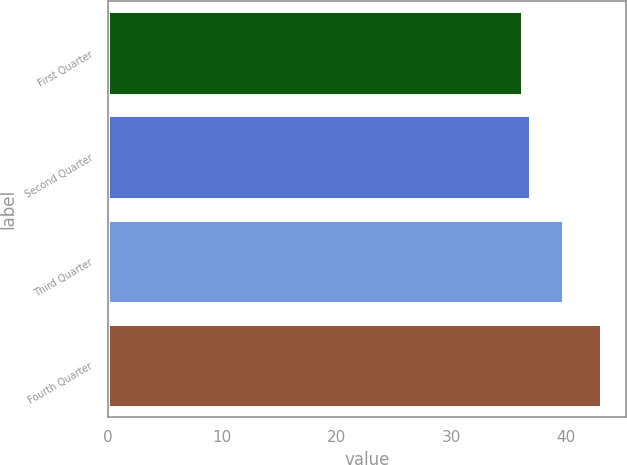<chart> <loc_0><loc_0><loc_500><loc_500><bar_chart><fcel>First Quarter<fcel>Second Quarter<fcel>Third Quarter<fcel>Fourth Quarter<nl><fcel>36.15<fcel>36.84<fcel>39.79<fcel>43.1<nl></chart> 